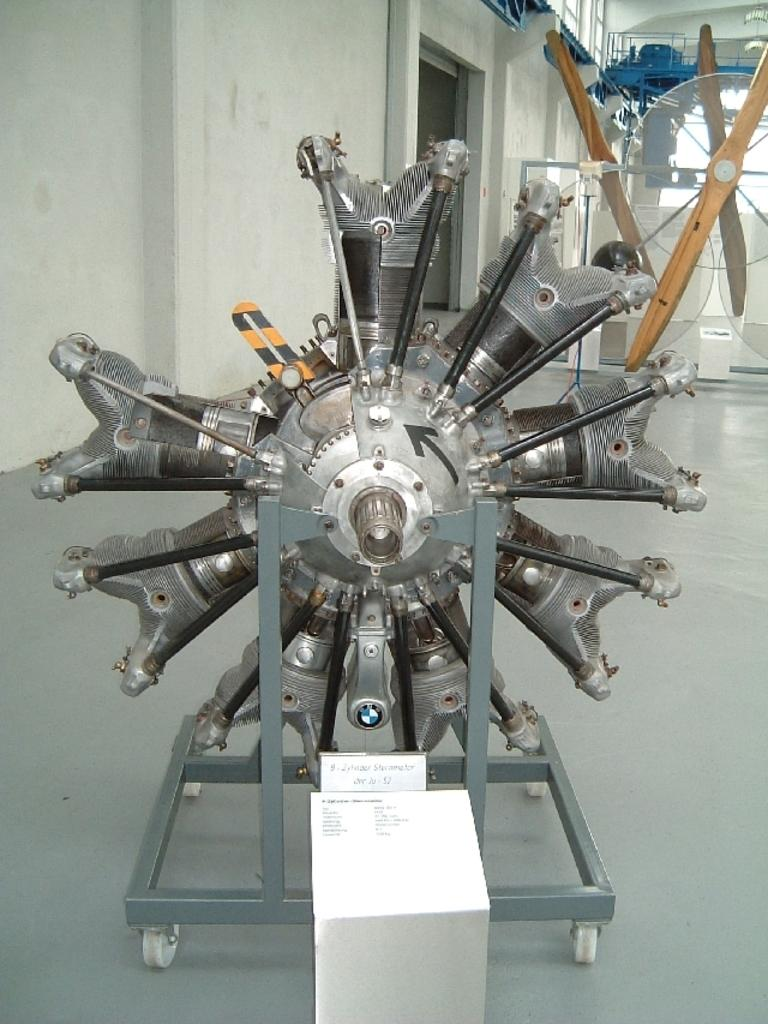What is the main object in the foreground of the image? There is a metal object in the foreground of the image. What can be seen in the background of the image? There are other objects, poles, and a wall in the background of the image. What is the surface on which the objects are placed? There is a floor at the bottom of the image. Can you describe another object in the image? There is a board in the image. What type of ear is visible on the metal object in the image? There is no ear present on the metal object in the image. What game is being played on the board in the image? There is no game being played on the board in the image; it is just a plain board. 